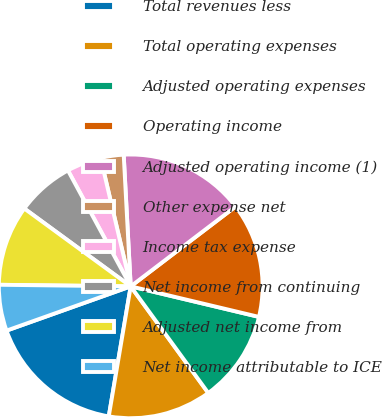<chart> <loc_0><loc_0><loc_500><loc_500><pie_chart><fcel>Total revenues less<fcel>Total operating expenses<fcel>Adjusted operating expenses<fcel>Operating income<fcel>Adjusted operating income (1)<fcel>Other expense net<fcel>Income tax expense<fcel>Net income from continuing<fcel>Adjusted net income from<fcel>Net income attributable to ICE<nl><fcel>16.89%<fcel>12.67%<fcel>11.27%<fcel>14.08%<fcel>15.49%<fcel>2.82%<fcel>4.23%<fcel>7.05%<fcel>9.86%<fcel>5.64%<nl></chart> 